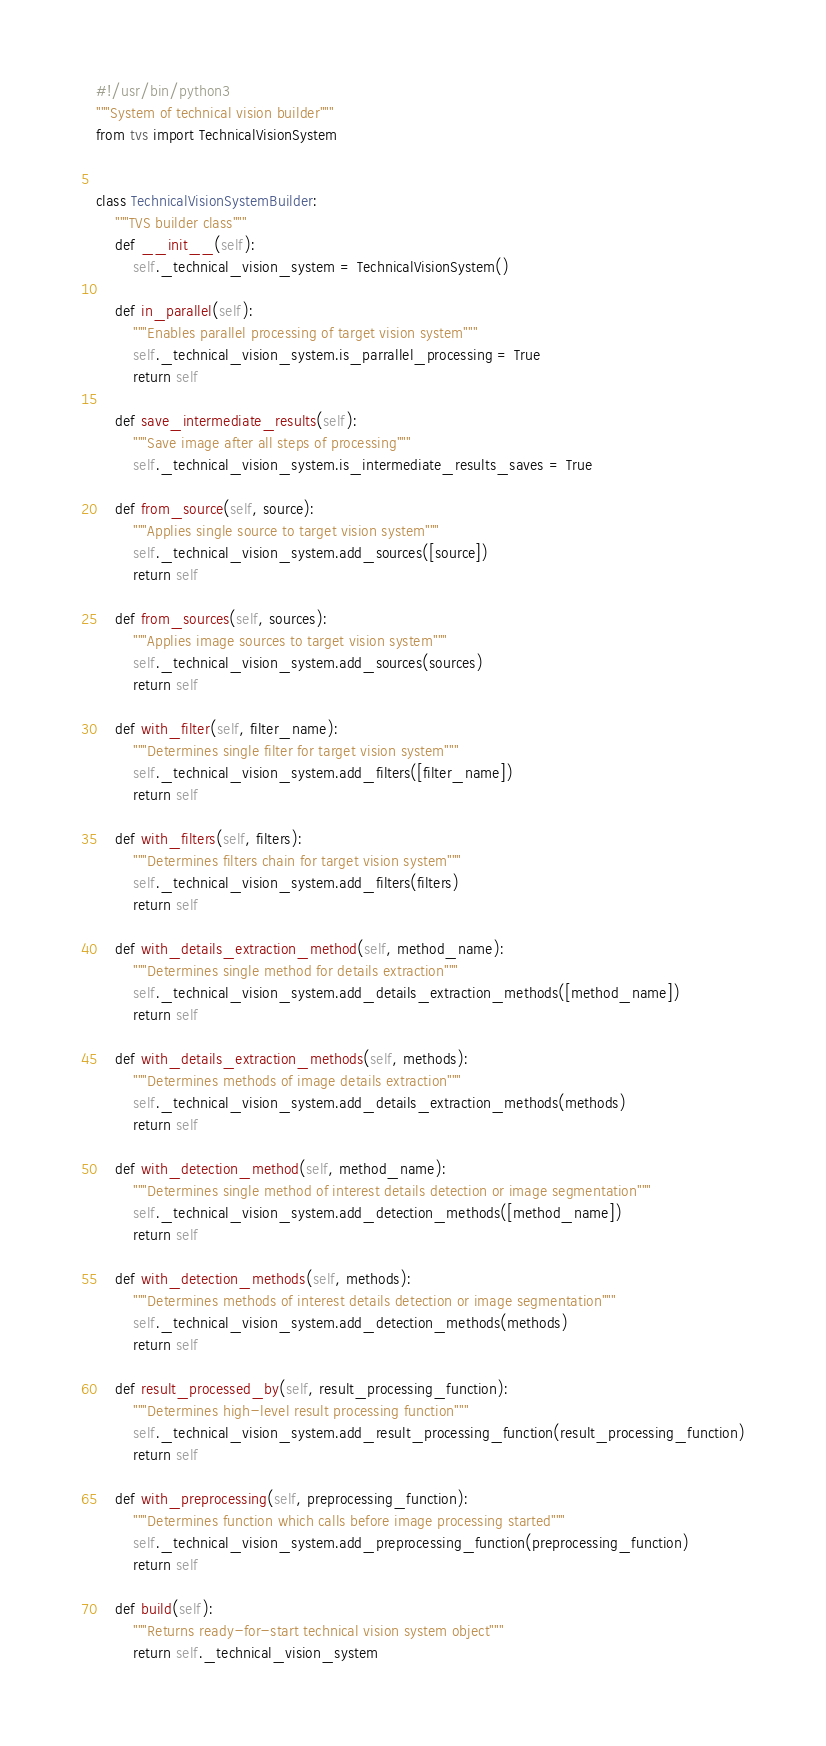Convert code to text. <code><loc_0><loc_0><loc_500><loc_500><_Python_>#!/usr/bin/python3
"""System of technical vision builder"""
from tvs import TechnicalVisionSystem


class TechnicalVisionSystemBuilder:
    """TVS builder class"""
    def __init__(self):
        self._technical_vision_system = TechnicalVisionSystem()

    def in_parallel(self):
        """Enables parallel processing of target vision system"""
        self._technical_vision_system.is_parrallel_processing = True
        return self

    def save_intermediate_results(self):
        """Save image after all steps of processing"""
        self._technical_vision_system.is_intermediate_results_saves = True

    def from_source(self, source):
        """Applies single source to target vision system"""
        self._technical_vision_system.add_sources([source])
        return self

    def from_sources(self, sources):
        """Applies image sources to target vision system"""
        self._technical_vision_system.add_sources(sources)
        return self

    def with_filter(self, filter_name):
        """Determines single filter for target vision system"""
        self._technical_vision_system.add_filters([filter_name])
        return self

    def with_filters(self, filters):
        """Determines filters chain for target vision system"""
        self._technical_vision_system.add_filters(filters)
        return self

    def with_details_extraction_method(self, method_name):
        """Determines single method for details extraction"""
        self._technical_vision_system.add_details_extraction_methods([method_name])
        return self

    def with_details_extraction_methods(self, methods):
        """Determines methods of image details extraction"""
        self._technical_vision_system.add_details_extraction_methods(methods)
        return self

    def with_detection_method(self, method_name):
        """Determines single method of interest details detection or image segmentation"""
        self._technical_vision_system.add_detection_methods([method_name])
        return self

    def with_detection_methods(self, methods):
        """Determines methods of interest details detection or image segmentation"""
        self._technical_vision_system.add_detection_methods(methods)
        return self

    def result_processed_by(self, result_processing_function):
        """Determines high-level result processing function"""
        self._technical_vision_system.add_result_processing_function(result_processing_function)
        return self

    def with_preprocessing(self, preprocessing_function):
        """Determines function which calls before image processing started"""
        self._technical_vision_system.add_preprocessing_function(preprocessing_function)
        return self

    def build(self):
        """Returns ready-for-start technical vision system object"""
        return self._technical_vision_system
</code> 